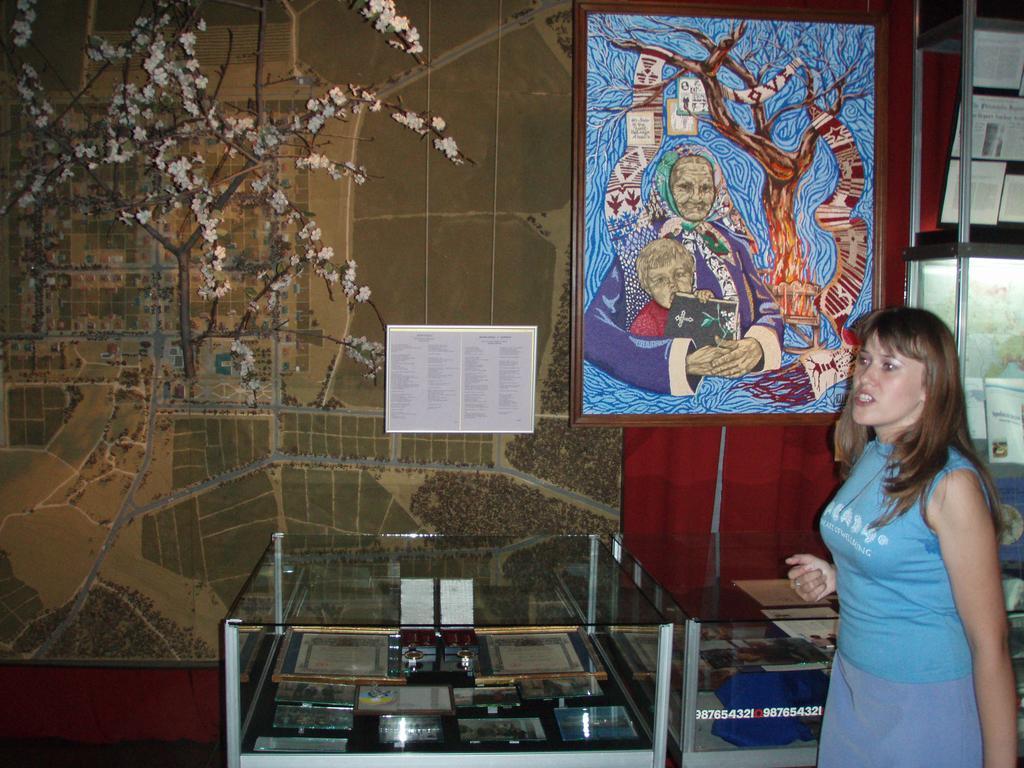Could you give a brief overview of what you see in this image? In the image on the right side there is a lady standing. Behind her there are glass tables with many objects in it. In the background on the wall there is a wallpaper and also there is a frame with painting. And also there are papers with text on it. Beside the frame there is a cupboard with many racks and there are some other things. 